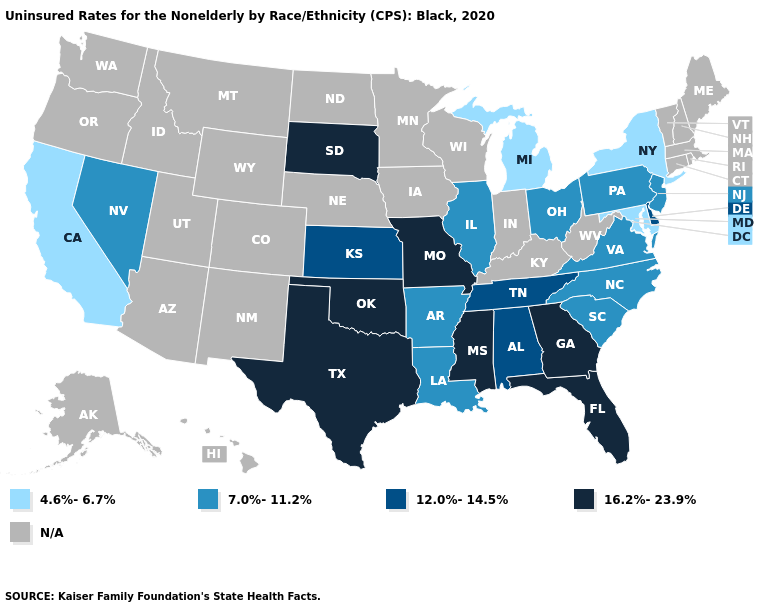Among the states that border South Carolina , which have the highest value?
Quick response, please. Georgia. What is the value of Oregon?
Short answer required. N/A. Name the states that have a value in the range N/A?
Concise answer only. Alaska, Arizona, Colorado, Connecticut, Hawaii, Idaho, Indiana, Iowa, Kentucky, Maine, Massachusetts, Minnesota, Montana, Nebraska, New Hampshire, New Mexico, North Dakota, Oregon, Rhode Island, Utah, Vermont, Washington, West Virginia, Wisconsin, Wyoming. Name the states that have a value in the range 4.6%-6.7%?
Be succinct. California, Maryland, Michigan, New York. Does Missouri have the highest value in the USA?
Give a very brief answer. Yes. What is the value of Tennessee?
Give a very brief answer. 12.0%-14.5%. What is the value of California?
Be succinct. 4.6%-6.7%. Name the states that have a value in the range 12.0%-14.5%?
Answer briefly. Alabama, Delaware, Kansas, Tennessee. Does the map have missing data?
Concise answer only. Yes. What is the value of Washington?
Short answer required. N/A. Name the states that have a value in the range 16.2%-23.9%?
Short answer required. Florida, Georgia, Mississippi, Missouri, Oklahoma, South Dakota, Texas. Which states have the highest value in the USA?
Answer briefly. Florida, Georgia, Mississippi, Missouri, Oklahoma, South Dakota, Texas. What is the value of Illinois?
Answer briefly. 7.0%-11.2%. Does the first symbol in the legend represent the smallest category?
Concise answer only. Yes. Which states have the lowest value in the West?
Answer briefly. California. 